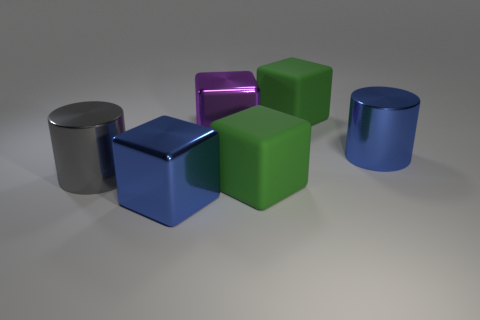What material is the big cylinder that is left of the matte cube behind the big gray metallic object that is in front of the big purple thing made of?
Your answer should be very brief. Metal. There is a gray shiny object that is the same size as the blue cylinder; what shape is it?
Keep it short and to the point. Cylinder. How big is the gray metallic object?
Your response must be concise. Large. Are the big purple cube and the big gray cylinder made of the same material?
Provide a short and direct response. Yes. How many big green blocks are on the right side of the large matte cube in front of the shiny cylinder right of the big purple metal object?
Ensure brevity in your answer.  1. The rubber thing that is behind the purple metallic object has what shape?
Your response must be concise. Cube. How many other things are made of the same material as the big gray thing?
Your response must be concise. 3. Is the number of big purple metallic things to the right of the big blue metal cube less than the number of blocks behind the large gray cylinder?
Your answer should be compact. Yes. There is another shiny object that is the same shape as the gray object; what is its color?
Offer a very short reply. Blue. Are there fewer blue cylinders that are in front of the gray cylinder than blue metal cubes?
Provide a short and direct response. Yes. 